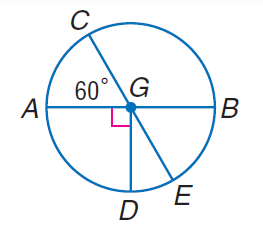Answer the mathemtical geometry problem and directly provide the correct option letter.
Question: Find m \angle D G E.
Choices: A: 30 B: 60 C: 150 D: 330 A 